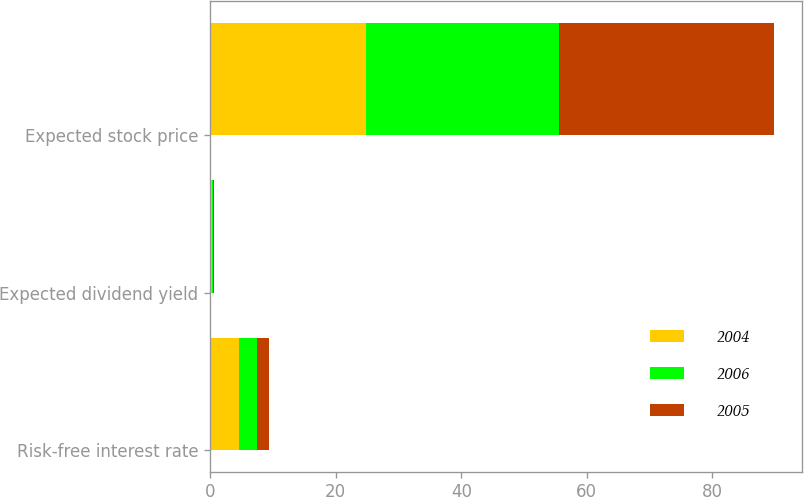Convert chart to OTSL. <chart><loc_0><loc_0><loc_500><loc_500><stacked_bar_chart><ecel><fcel>Risk-free interest rate<fcel>Expected dividend yield<fcel>Expected stock price<nl><fcel>2004<fcel>4.6<fcel>0.2<fcel>24.8<nl><fcel>2006<fcel>2.9<fcel>0.2<fcel>30.7<nl><fcel>2005<fcel>1.9<fcel>0.2<fcel>34.3<nl></chart> 